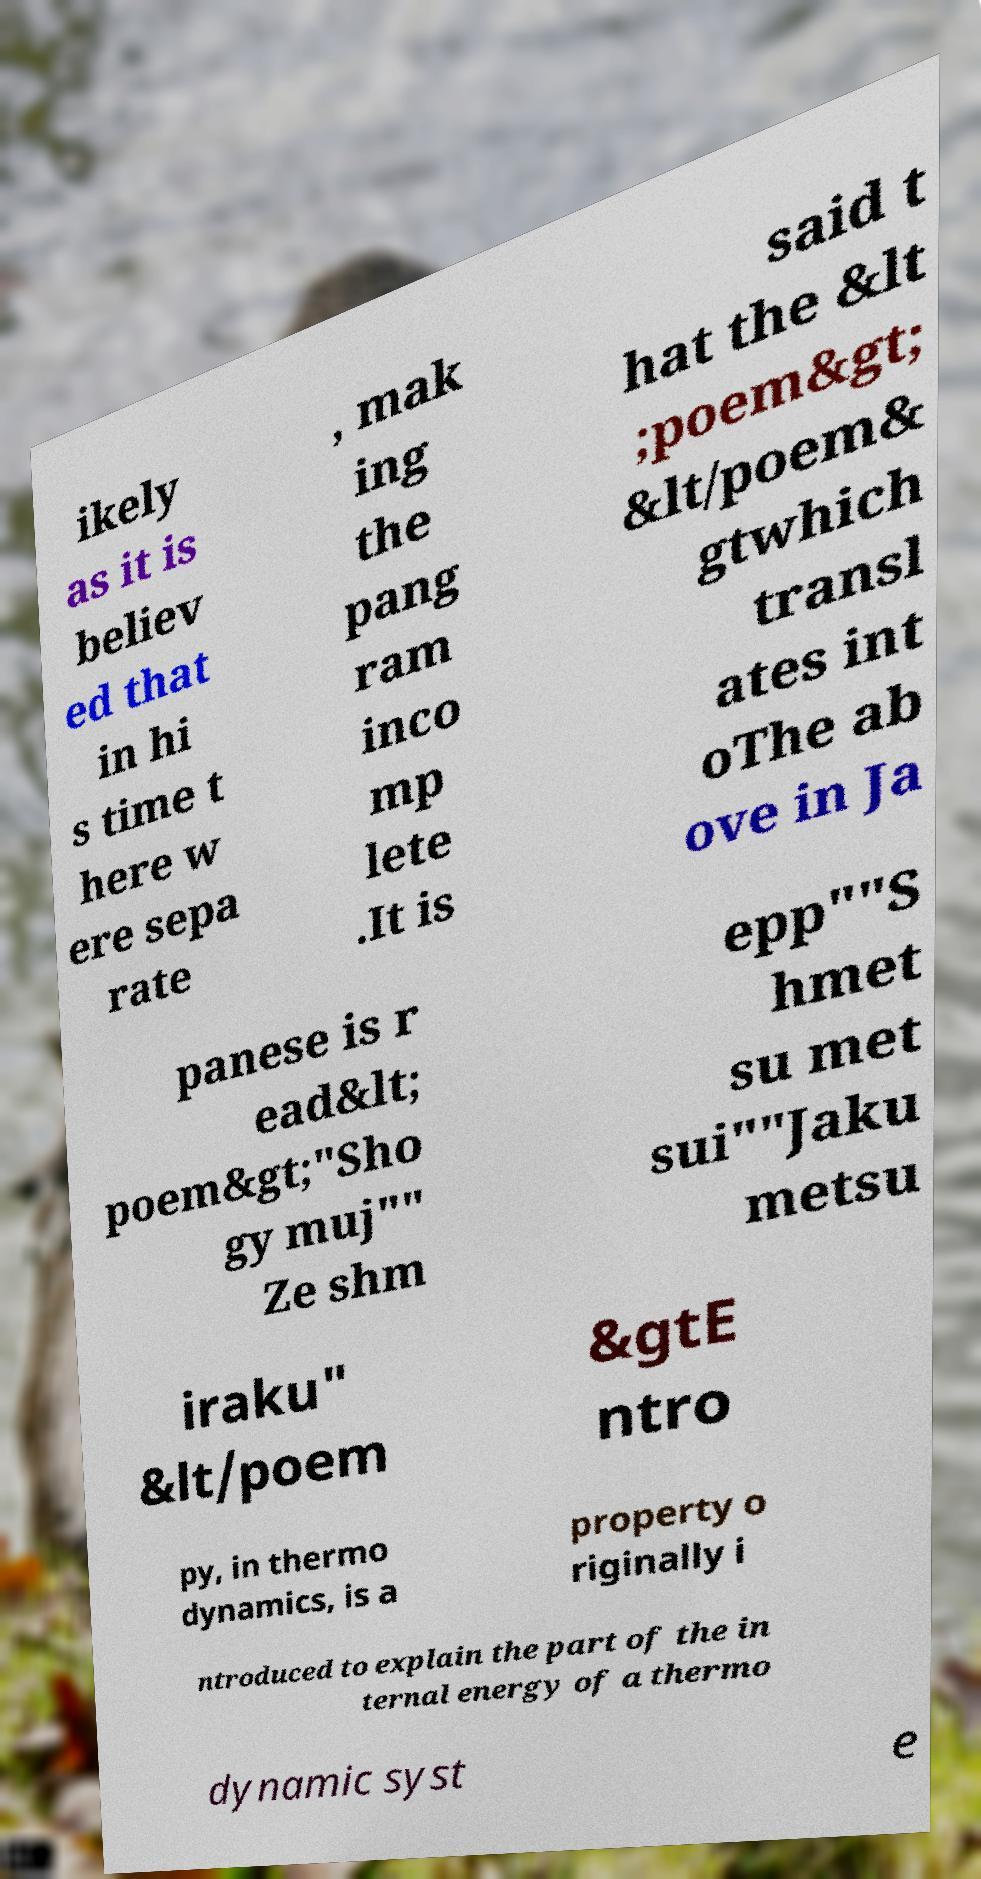For documentation purposes, I need the text within this image transcribed. Could you provide that? ikely as it is believ ed that in hi s time t here w ere sepa rate , mak ing the pang ram inco mp lete .It is said t hat the &lt ;poem&gt; &lt/poem& gtwhich transl ates int oThe ab ove in Ja panese is r ead&lt; poem&gt;"Sho gy muj"" Ze shm epp""S hmet su met sui""Jaku metsu iraku" &lt/poem &gtE ntro py, in thermo dynamics, is a property o riginally i ntroduced to explain the part of the in ternal energy of a thermo dynamic syst e 